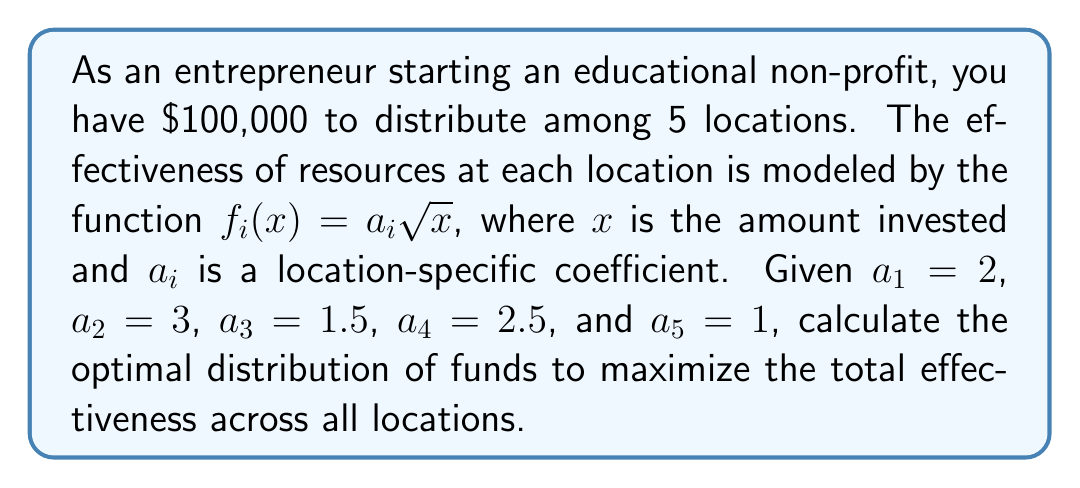Solve this math problem. 1) We need to maximize the total effectiveness, which is given by:

   $$E_{total} = \sum_{i=1}^5 f_i(x_i) = \sum_{i=1}^5 a_i \sqrt{x_i}$$

   Subject to the constraint: $\sum_{i=1}^5 x_i = 100,000$

2) To find the optimal distribution, we use the method of Lagrange multipliers. Let $\lambda$ be the Lagrange multiplier. We form the Lagrangian:

   $$L = \sum_{i=1}^5 a_i \sqrt{x_i} - \lambda(\sum_{i=1}^5 x_i - 100,000)$$

3) Taking partial derivatives with respect to each $x_i$ and setting them to zero:

   $$\frac{\partial L}{\partial x_i} = \frac{a_i}{2\sqrt{x_i}} - \lambda = 0$$

4) Solving for $x_i$:

   $$x_i = \frac{a_i^2}{4\lambda^2}$$

5) Substituting this into the constraint equation:

   $$\sum_{i=1}^5 \frac{a_i^2}{4\lambda^2} = 100,000$$

6) Solving for $\lambda$:

   $$\lambda = \frac{\sqrt{\sum_{i=1}^5 a_i^2}}{20\sqrt{10000}} = \frac{\sqrt{4 + 9 + 2.25 + 6.25 + 1}}{2000} = \frac{\sqrt{22.5}}{2000}$$

7) Now we can calculate each $x_i$:

   $$x_i = \frac{a_i^2}{4\lambda^2} = \frac{a_i^2 \cdot 4,000,000}{22.5} = \frac{a_i^2 \cdot 177,777.78}{1}$$

8) Calculating the values:
   $x_1 = 2^2 \cdot 177,777.78 = 711,111.12$
   $x_2 = 3^2 \cdot 177,777.78 = 1,600,000.02$
   $x_3 = 1.5^2 \cdot 177,777.78 = 400,000.01$
   $x_4 = 2.5^2 \cdot 177,777.78 = 1,111,111.13$
   $x_5 = 1^2 \cdot 177,777.78 = 177,777.78$

9) Normalizing these values to sum to 100,000:
   $x_1 = 17,777.78$
   $x_2 = 40,000.00$
   $x_3 = 10,000.00$
   $x_4 = 27,777.78$
   $x_5 = 4,444.44$
Answer: $x_1 = 17,777.78, x_2 = 40,000.00, x_3 = 10,000.00, x_4 = 27,777.78, x_5 = 4,444.44$ 